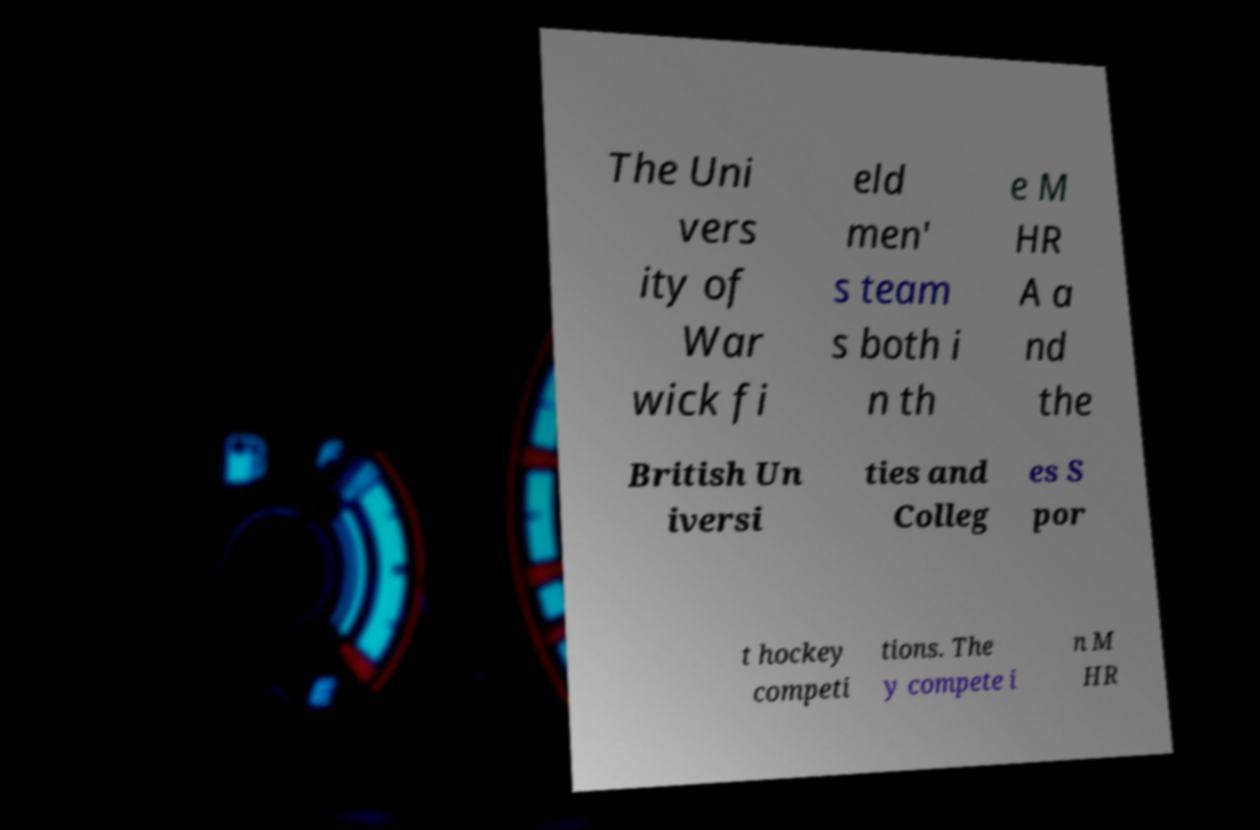Can you accurately transcribe the text from the provided image for me? The Uni vers ity of War wick fi eld men' s team s both i n th e M HR A a nd the British Un iversi ties and Colleg es S por t hockey competi tions. The y compete i n M HR 